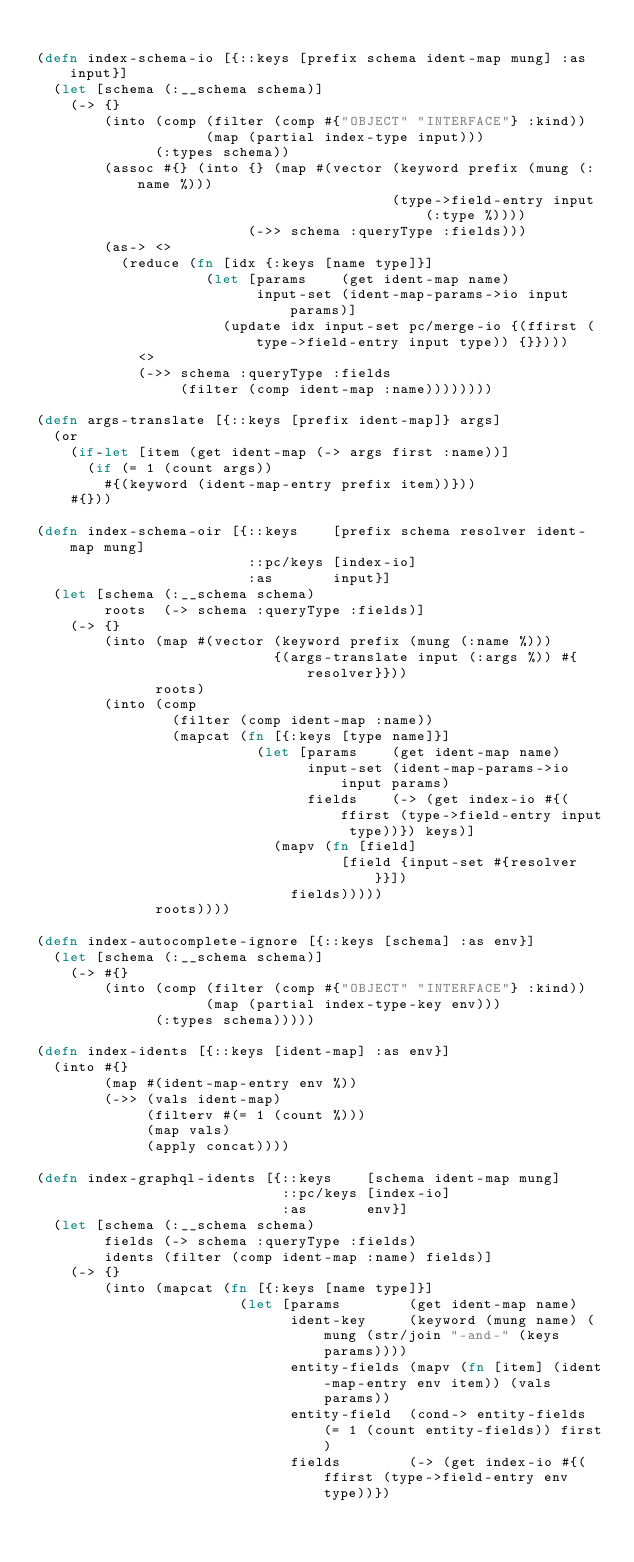Convert code to text. <code><loc_0><loc_0><loc_500><loc_500><_Clojure_>
(defn index-schema-io [{::keys [prefix schema ident-map mung] :as input}]
  (let [schema (:__schema schema)]
    (-> {}
        (into (comp (filter (comp #{"OBJECT" "INTERFACE"} :kind))
                    (map (partial index-type input)))
              (:types schema))
        (assoc #{} (into {} (map #(vector (keyword prefix (mung (:name %)))
                                          (type->field-entry input (:type %))))
                         (->> schema :queryType :fields)))
        (as-> <>
          (reduce (fn [idx {:keys [name type]}]
                    (let [params    (get ident-map name)
                          input-set (ident-map-params->io input params)]
                      (update idx input-set pc/merge-io {(ffirst (type->field-entry input type)) {}})))
            <>
            (->> schema :queryType :fields
                 (filter (comp ident-map :name))))))))

(defn args-translate [{::keys [prefix ident-map]} args]
  (or
    (if-let [item (get ident-map (-> args first :name))]
      (if (= 1 (count args))
        #{(keyword (ident-map-entry prefix item))}))
    #{}))

(defn index-schema-oir [{::keys    [prefix schema resolver ident-map mung]
                         ::pc/keys [index-io]
                         :as       input}]
  (let [schema (:__schema schema)
        roots  (-> schema :queryType :fields)]
    (-> {}
        (into (map #(vector (keyword prefix (mung (:name %)))
                            {(args-translate input (:args %)) #{resolver}}))
              roots)
        (into (comp
                (filter (comp ident-map :name))
                (mapcat (fn [{:keys [type name]}]
                          (let [params    (get ident-map name)
                                input-set (ident-map-params->io input params)
                                fields    (-> (get index-io #{(ffirst (type->field-entry input type))}) keys)]
                            (mapv (fn [field]
                                    [field {input-set #{resolver}}])
                              fields)))))
              roots))))

(defn index-autocomplete-ignore [{::keys [schema] :as env}]
  (let [schema (:__schema schema)]
    (-> #{}
        (into (comp (filter (comp #{"OBJECT" "INTERFACE"} :kind))
                    (map (partial index-type-key env)))
              (:types schema)))))

(defn index-idents [{::keys [ident-map] :as env}]
  (into #{}
        (map #(ident-map-entry env %))
        (->> (vals ident-map)
             (filterv #(= 1 (count %)))
             (map vals)
             (apply concat))))

(defn index-graphql-idents [{::keys    [schema ident-map mung]
                             ::pc/keys [index-io]
                             :as       env}]
  (let [schema (:__schema schema)
        fields (-> schema :queryType :fields)
        idents (filter (comp ident-map :name) fields)]
    (-> {}
        (into (mapcat (fn [{:keys [name type]}]
                        (let [params        (get ident-map name)
                              ident-key     (keyword (mung name) (mung (str/join "-and-" (keys params))))
                              entity-fields (mapv (fn [item] (ident-map-entry env item)) (vals params))
                              entity-field  (cond-> entity-fields (= 1 (count entity-fields)) first)
                              fields        (-> (get index-io #{(ffirst (type->field-entry env type))})</code> 